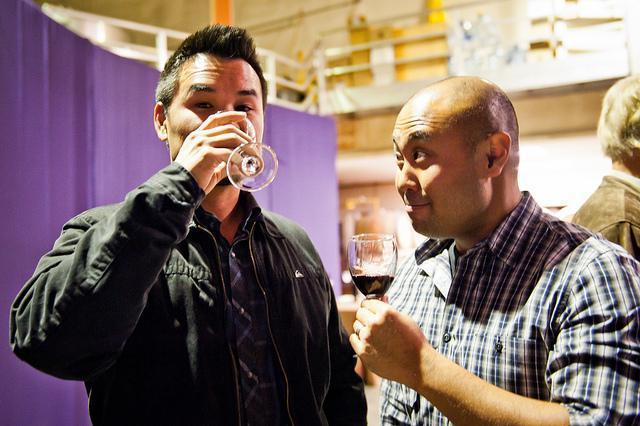How many people can you see?
Give a very brief answer. 3. How many wine glasses can you see?
Give a very brief answer. 2. 